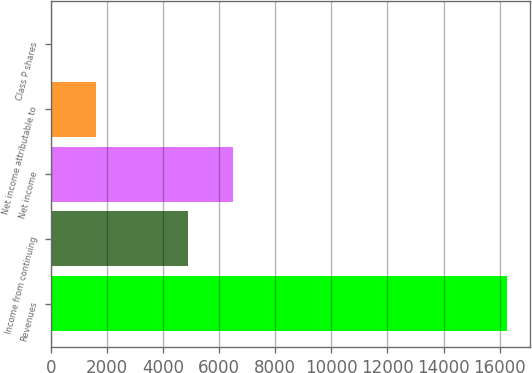Convert chart to OTSL. <chart><loc_0><loc_0><loc_500><loc_500><bar_chart><fcel>Revenues<fcel>Income from continuing<fcel>Net income<fcel>Net income attributable to<fcel>Class P shares<nl><fcel>16260<fcel>4878.63<fcel>6504.54<fcel>1626.81<fcel>0.9<nl></chart> 